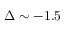<formula> <loc_0><loc_0><loc_500><loc_500>\Delta \sim - 1 . 5</formula> 